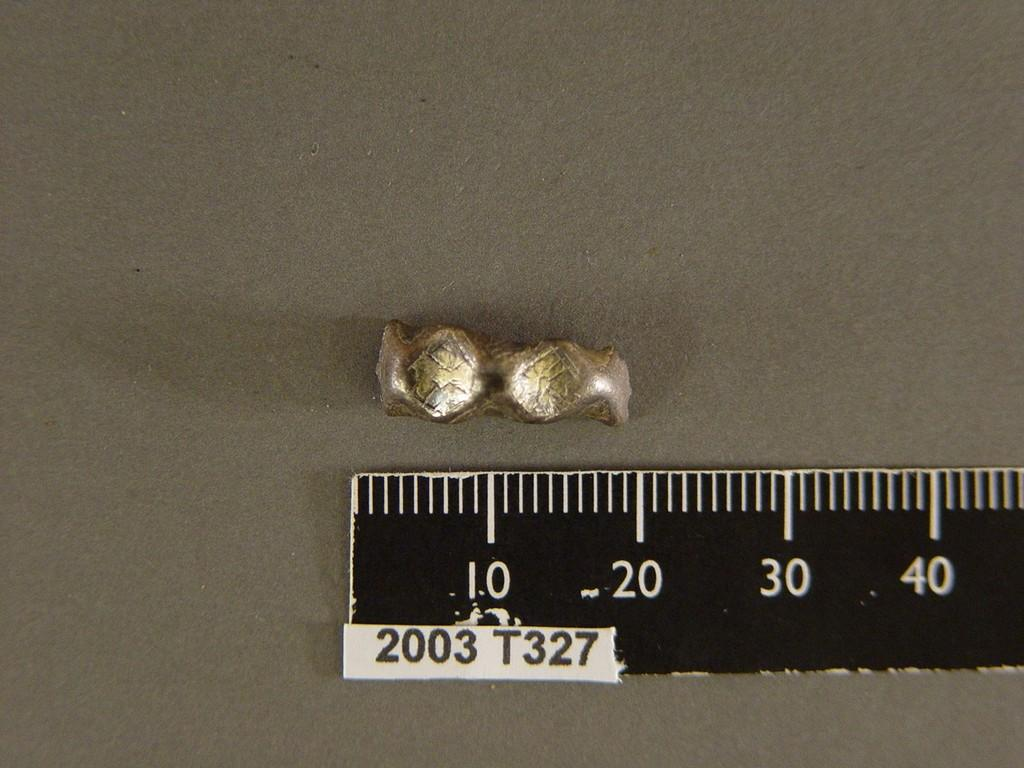<image>
Render a clear and concise summary of the photo. A 18mm slug of metal sits above a ruler labeled 2003 T327. 